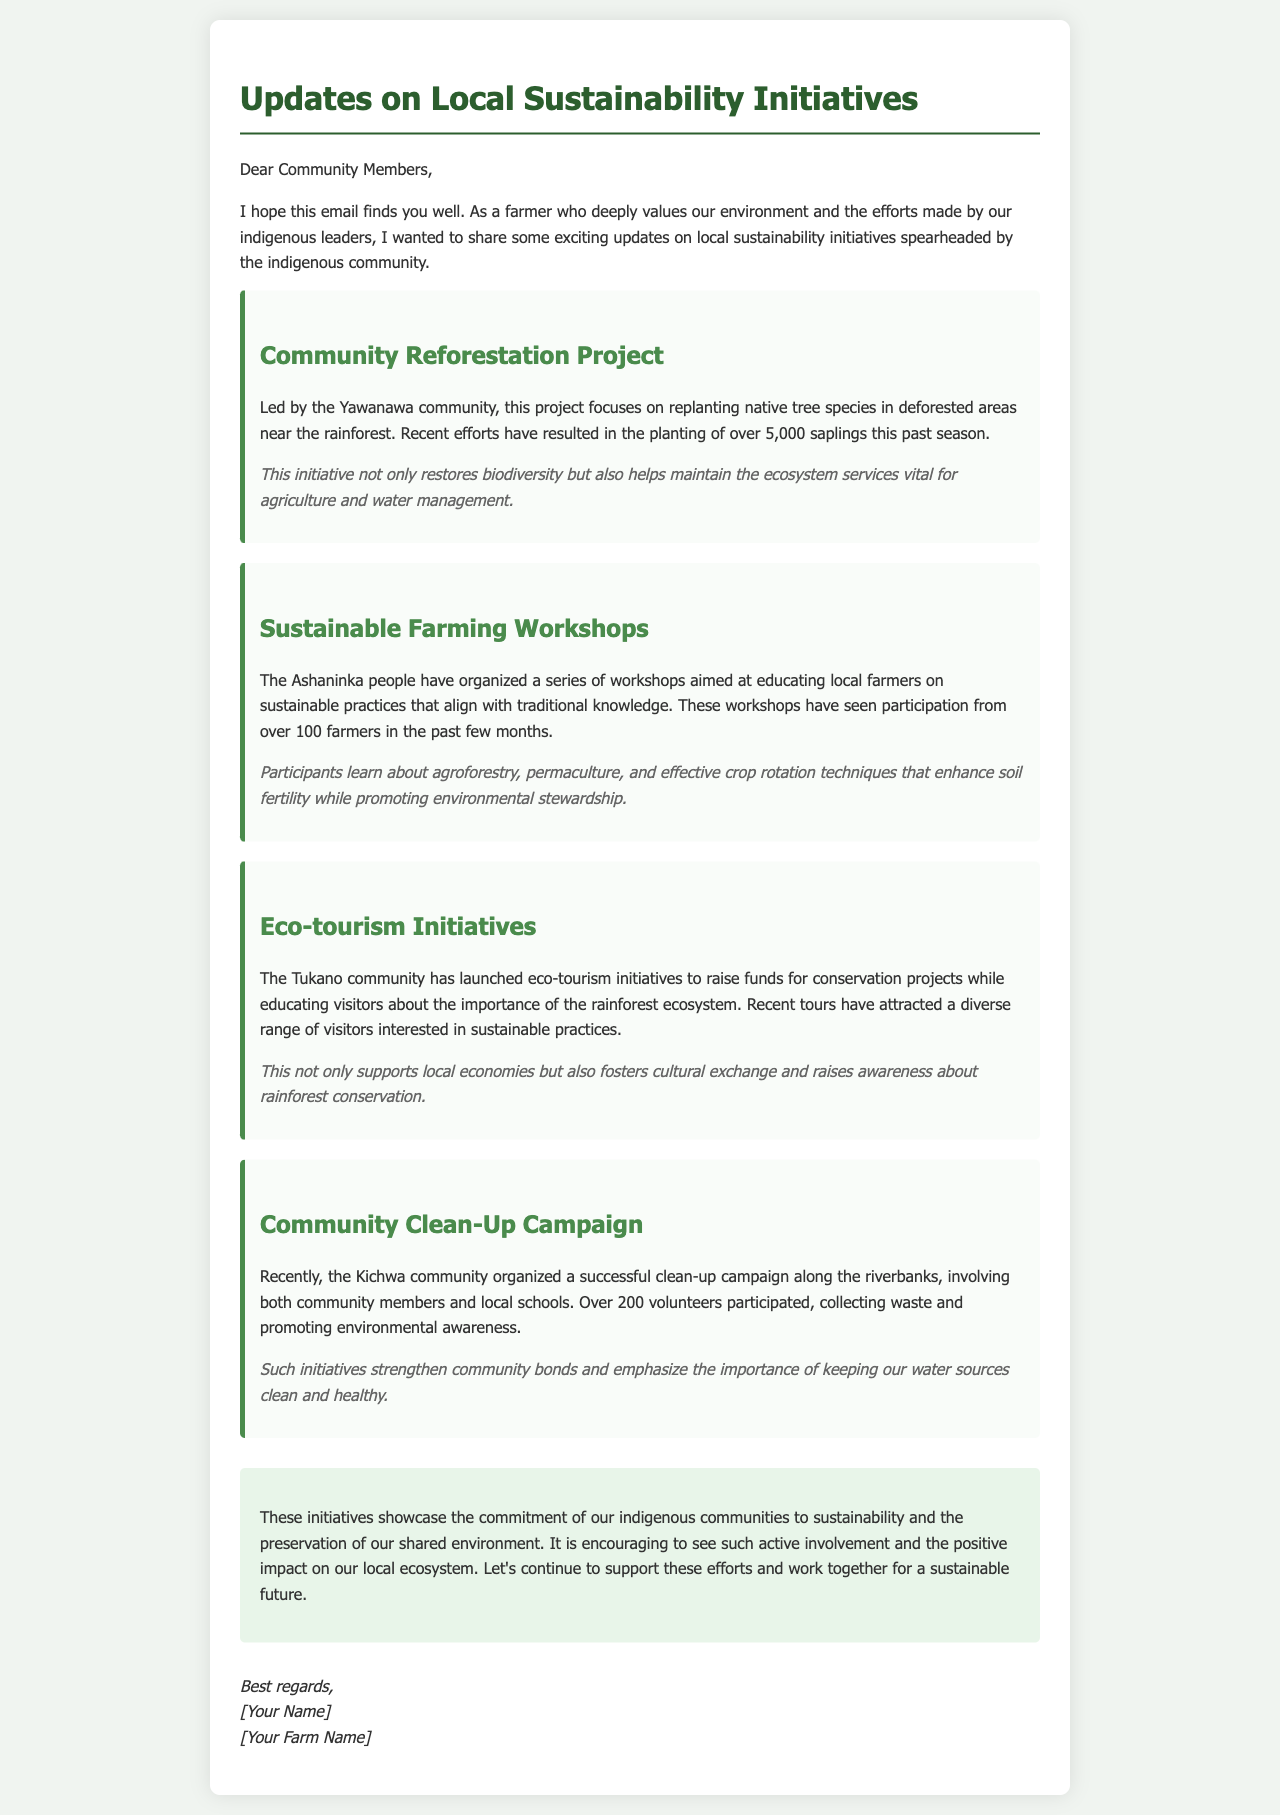What is the name of the community leading the reforestation project? The document states that the Yawanawa community is leading the reforestation project.
Answer: Yawanawa How many saplings were planted in the reforestation project? The document mentions that over 5,000 saplings were planted this past season.
Answer: 5,000 How many farmers participated in the sustainable farming workshops? The document reports that over 100 farmers participated in the workshops.
Answer: 100 What type of initiatives did the Tukano community launch? The document specifies that the Tukano community launched eco-tourism initiatives.
Answer: Eco-tourism initiatives How many volunteers participated in the community clean-up campaign? The document indicates that over 200 volunteers participated in the clean-up campaign.
Answer: 200 What is the main focus of the sustainable farming workshops? The document states that the workshops focus on educating local farmers on sustainable practices.
Answer: Sustainable practices Which community organized the clean-up campaign? The document reports that the Kichwa community organized the clean-up campaign.
Answer: Kichwa What is emphasized through the clean-up campaign according to the document? The document emphasizes the importance of keeping our water sources clean and healthy through the clean-up campaign.
Answer: Clean water sources What is the overall message of the email regarding community involvement? The conclusion of the document showcases the commitment of indigenous communities to sustainability through active involvement.
Answer: Commitment to sustainability 